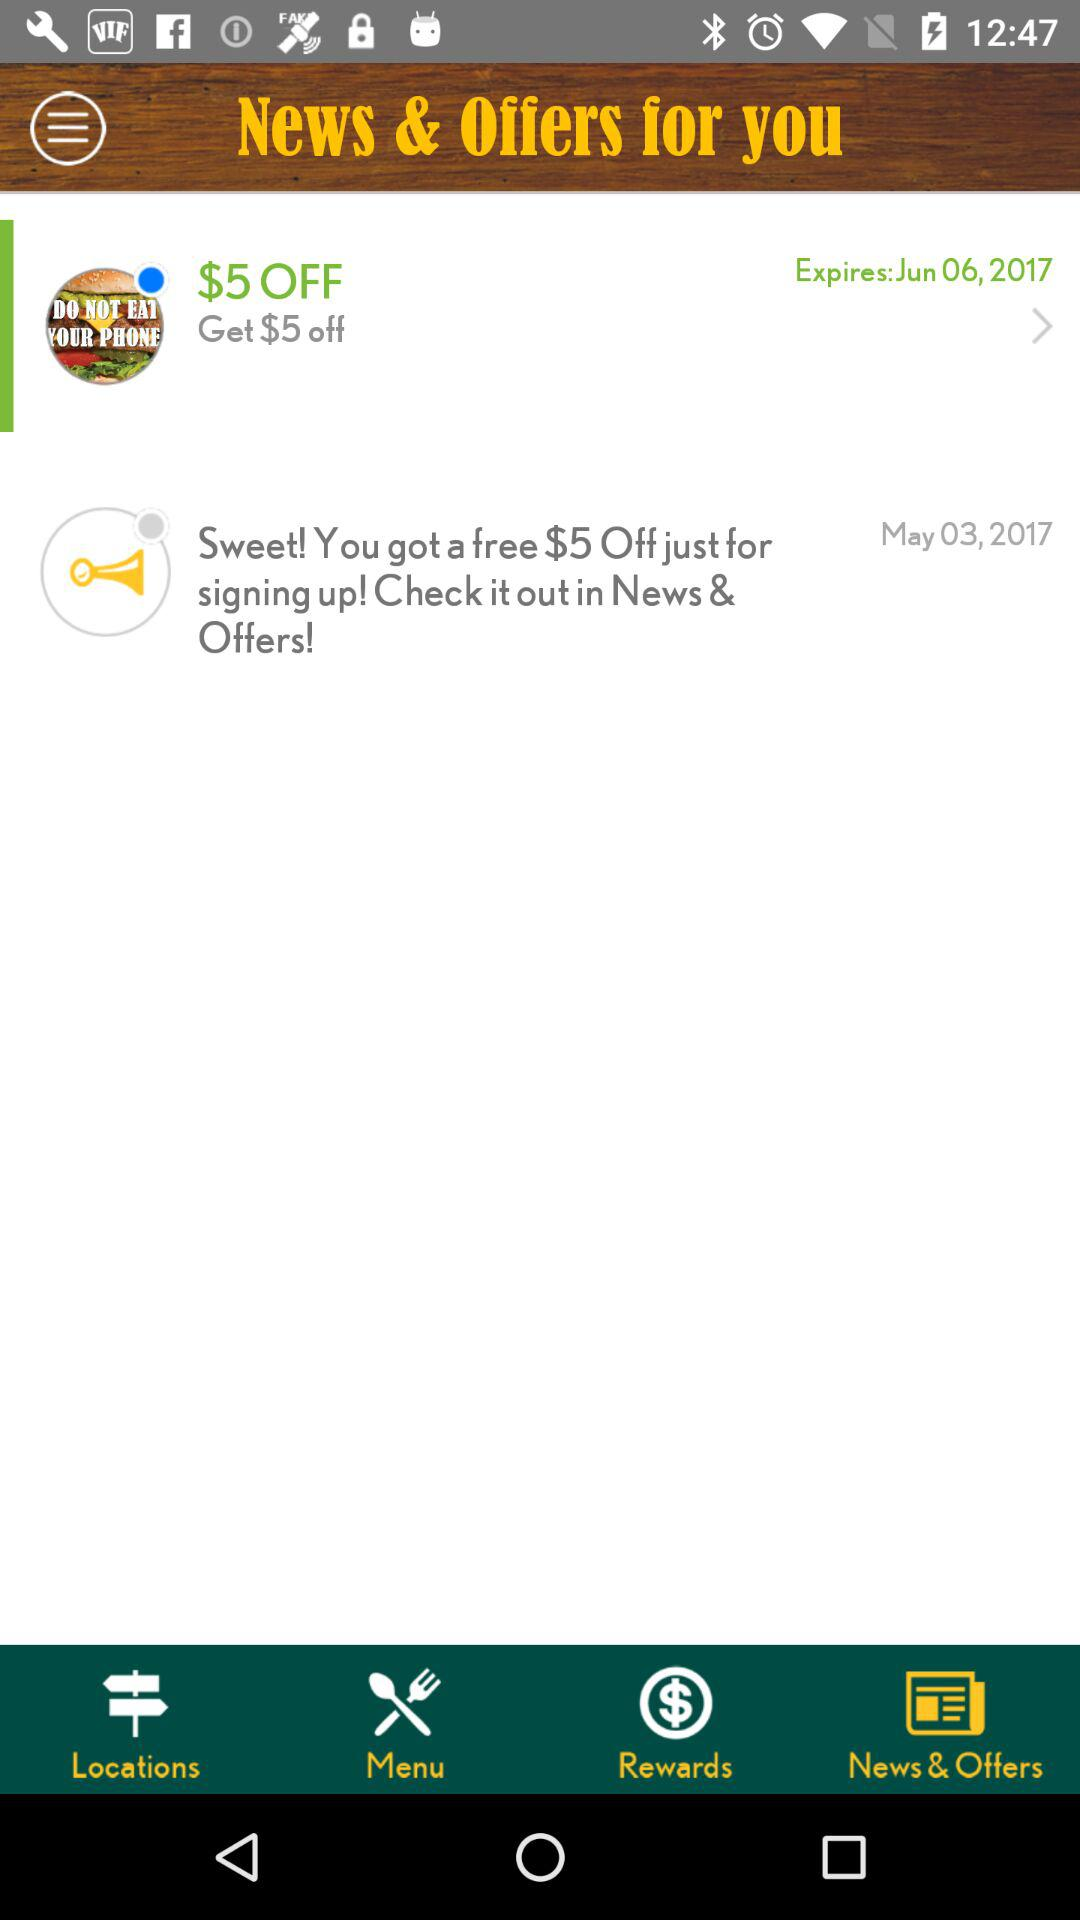What is the expiration date of "Get $5 off"? The expiration date of "Get $5 off" is June 6, 2017. 